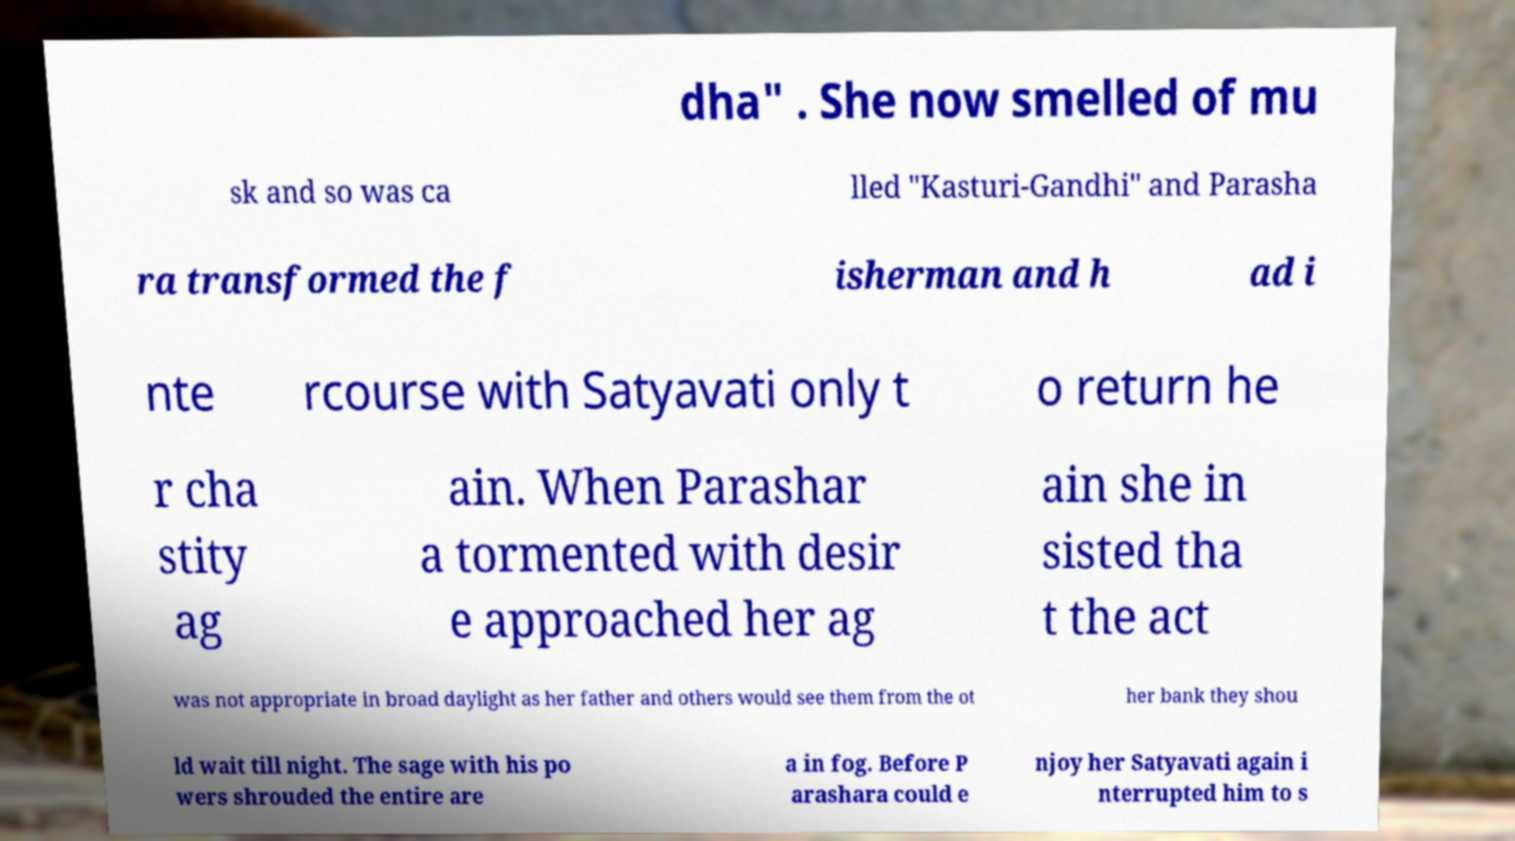Could you assist in decoding the text presented in this image and type it out clearly? dha" . She now smelled of mu sk and so was ca lled "Kasturi-Gandhi" and Parasha ra transformed the f isherman and h ad i nte rcourse with Satyavati only t o return he r cha stity ag ain. When Parashar a tormented with desir e approached her ag ain she in sisted tha t the act was not appropriate in broad daylight as her father and others would see them from the ot her bank they shou ld wait till night. The sage with his po wers shrouded the entire are a in fog. Before P arashara could e njoy her Satyavati again i nterrupted him to s 